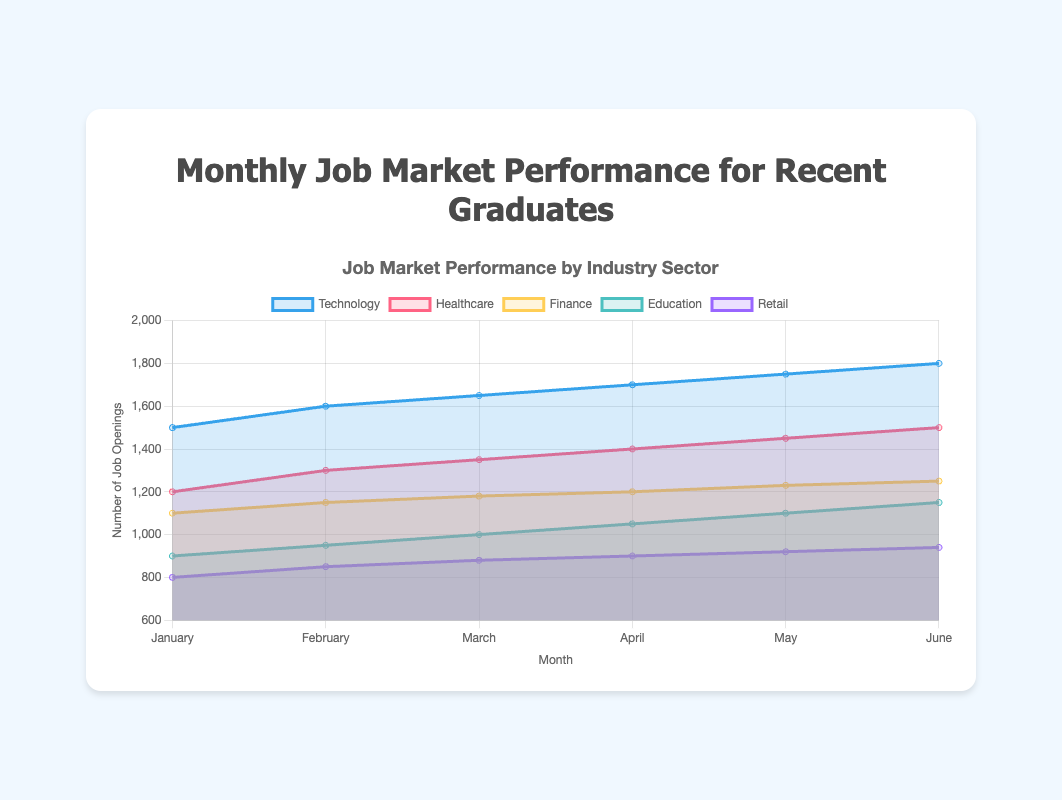What's the title of the figure? The title is written clearly at the top of the figure. It reads "Monthly Job Market Performance for Recent Graduates."
Answer: Monthly Job Market Performance for Recent Graduates Which industry sector had the highest number of job openings in June? By looking at the peak of the area chart in June, we can observe that the Technology sector has the highest position.
Answer: Technology How many months' worth of data is displayed in the chart? By counting the x-axis labels, we can see six distinct months listed from January to June.
Answer: Six months What's the average number of job openings in the Retail sector across all months? The sum of job openings in the Retail sector across the six months is (800 + 850 + 880 + 900 + 920 + 940) which equals 5290. Dividing by the six months gives an average of 5290/6.
Answer: 881.67 Did the Finance sector ever have more job openings than the Healthcare sector in any month? By comparing the relative height of the Finance and Healthcare areas on the chart for each month, we can see that the height of the Healthcare sector is always above the Finance sector.
Answer: No Which months show an increase in job openings for the Education sector? By tracking the rise of the area representing Education from month to month, increases are observed in February, March, April, May, and June.
Answer: February, March, April, May, June What is the total number of job openings in the Technology sector in all months combined? Adding the numbers from the Technology sector from each month: 1500 + 1600 + 1650 + 1700 + 1750 + 1800 equals 10000.
Answer: 10000 How does the trend in job openings for the Healthcare sector compare to that of the Finance sector? Both sectors show a general upward trend, but the Healthcare sector consistently has higher job openings than the Finance sector in each month.
Answer: Healthcare consistently higher What is the difference in job openings between the Technology and the Retail sectors in January? The number of job openings in January for Technology is 1500, and for Retail is 800. The difference is 1500 - 800.
Answer: 700 Which sector shows the least growth from January to June? By comparing the areas of each sector from January to June, Retail shows the smallest relative increase.
Answer: Retail 